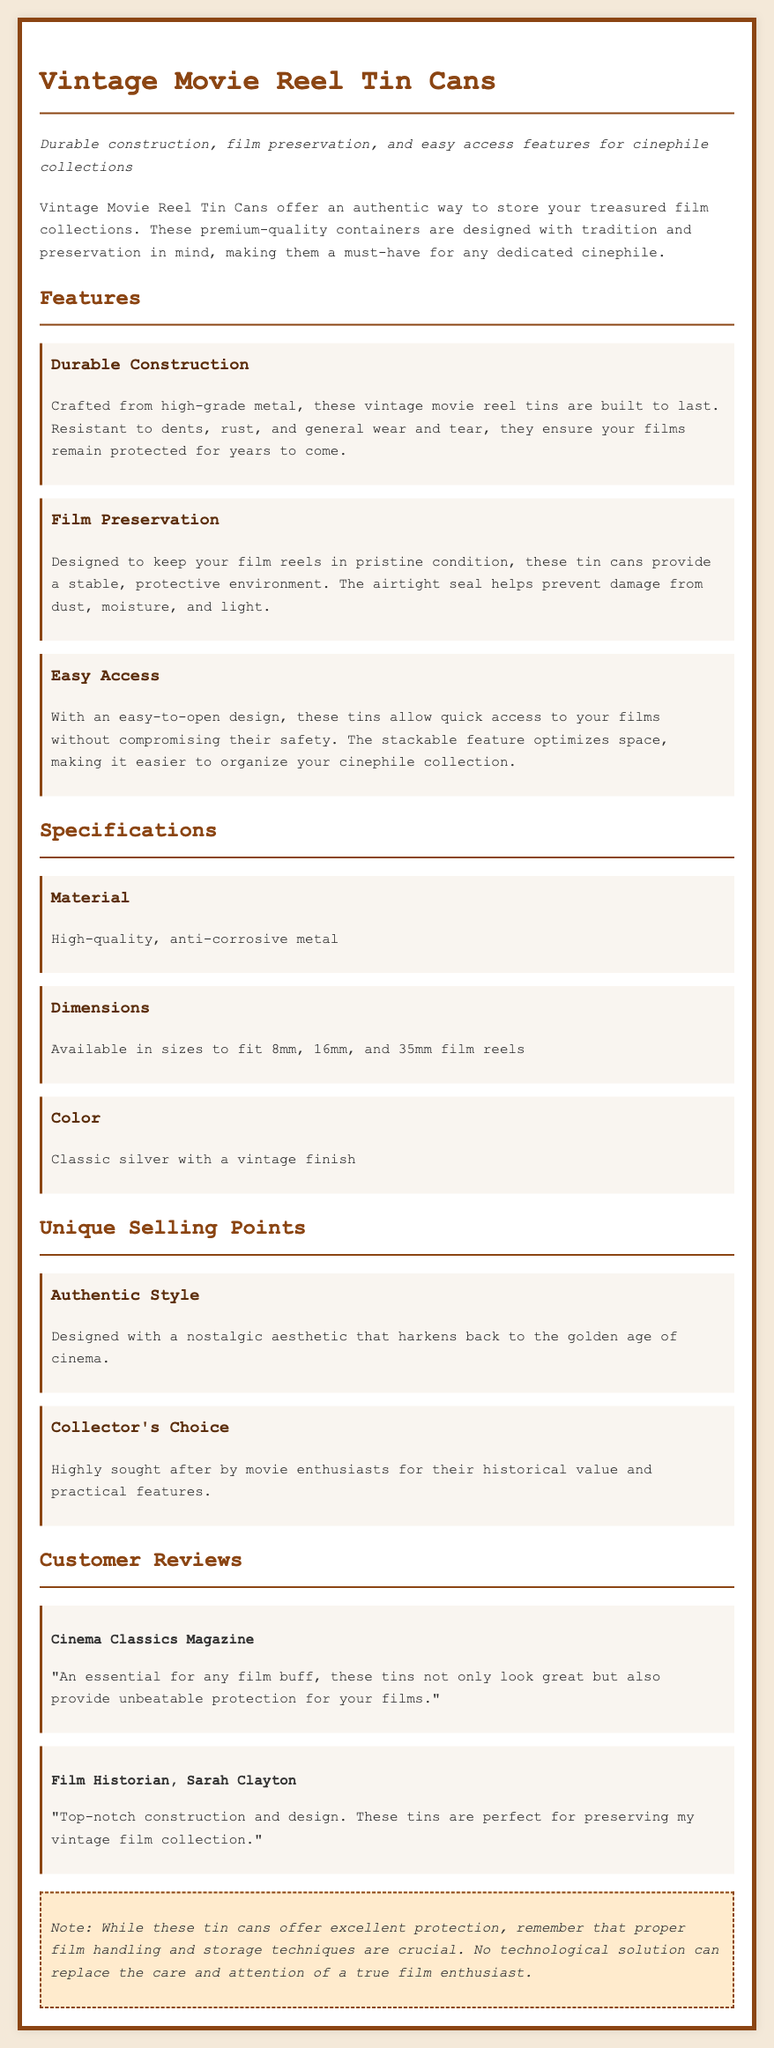what material are the tins made of? The document states that the tins are made from high-quality, anti-corrosive metal.
Answer: anti-corrosive metal what dimensions are available for the tins? The document indicates that the tins are available in sizes to fit 8mm, 16mm, and 35mm film reels.
Answer: 8mm, 16mm, and 35mm what is one feature that helps protect films? The document mentions that the airtight seal helps prevent damage from dust, moisture, and light.
Answer: airtight seal who reviewed the product for Cinema Classics Magazine? The document lists Cinema Classics Magazine as the reviewer of the product.
Answer: Cinema Classics Magazine what is the color of the vintage movie reel tin cans? The document specifies that the color of the tins is classic silver with a vintage finish.
Answer: classic silver with a vintage finish what is a unique feature of the tins according to cinephile preferences? The document states that the tins are highly sought after by movie enthusiasts for their historical value and practical features.
Answer: historical value and practical features what design feature allows for easy access to films? The document describes the tins as having an easy-to-open design, which allows for quick access to films.
Answer: easy-to-open design what aesthetic do the tins provide? The document highlights that the tins are designed with a nostalgic aesthetic that harkens back to the golden age of cinema.
Answer: nostalgic aesthetic what is a critical point made in the warning section? The warning section emphasizes that proper film handling and storage techniques are crucial.
Answer: proper film handling and storage techniques 